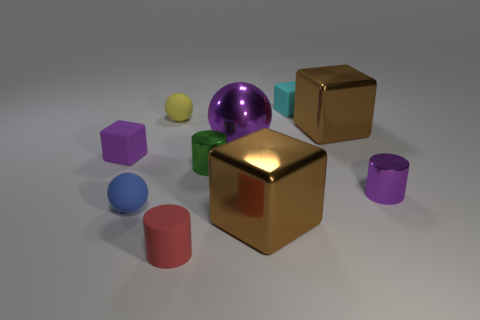Subtract all tiny balls. How many balls are left? 1 Subtract all brown blocks. How many blocks are left? 2 Subtract 3 cylinders. How many cylinders are left? 0 Subtract all yellow spheres. How many cyan blocks are left? 1 Subtract all big red matte balls. Subtract all tiny objects. How many objects are left? 3 Add 2 cyan objects. How many cyan objects are left? 3 Add 1 brown cylinders. How many brown cylinders exist? 1 Subtract 0 gray spheres. How many objects are left? 10 Subtract all spheres. How many objects are left? 7 Subtract all purple blocks. Subtract all yellow cylinders. How many blocks are left? 3 